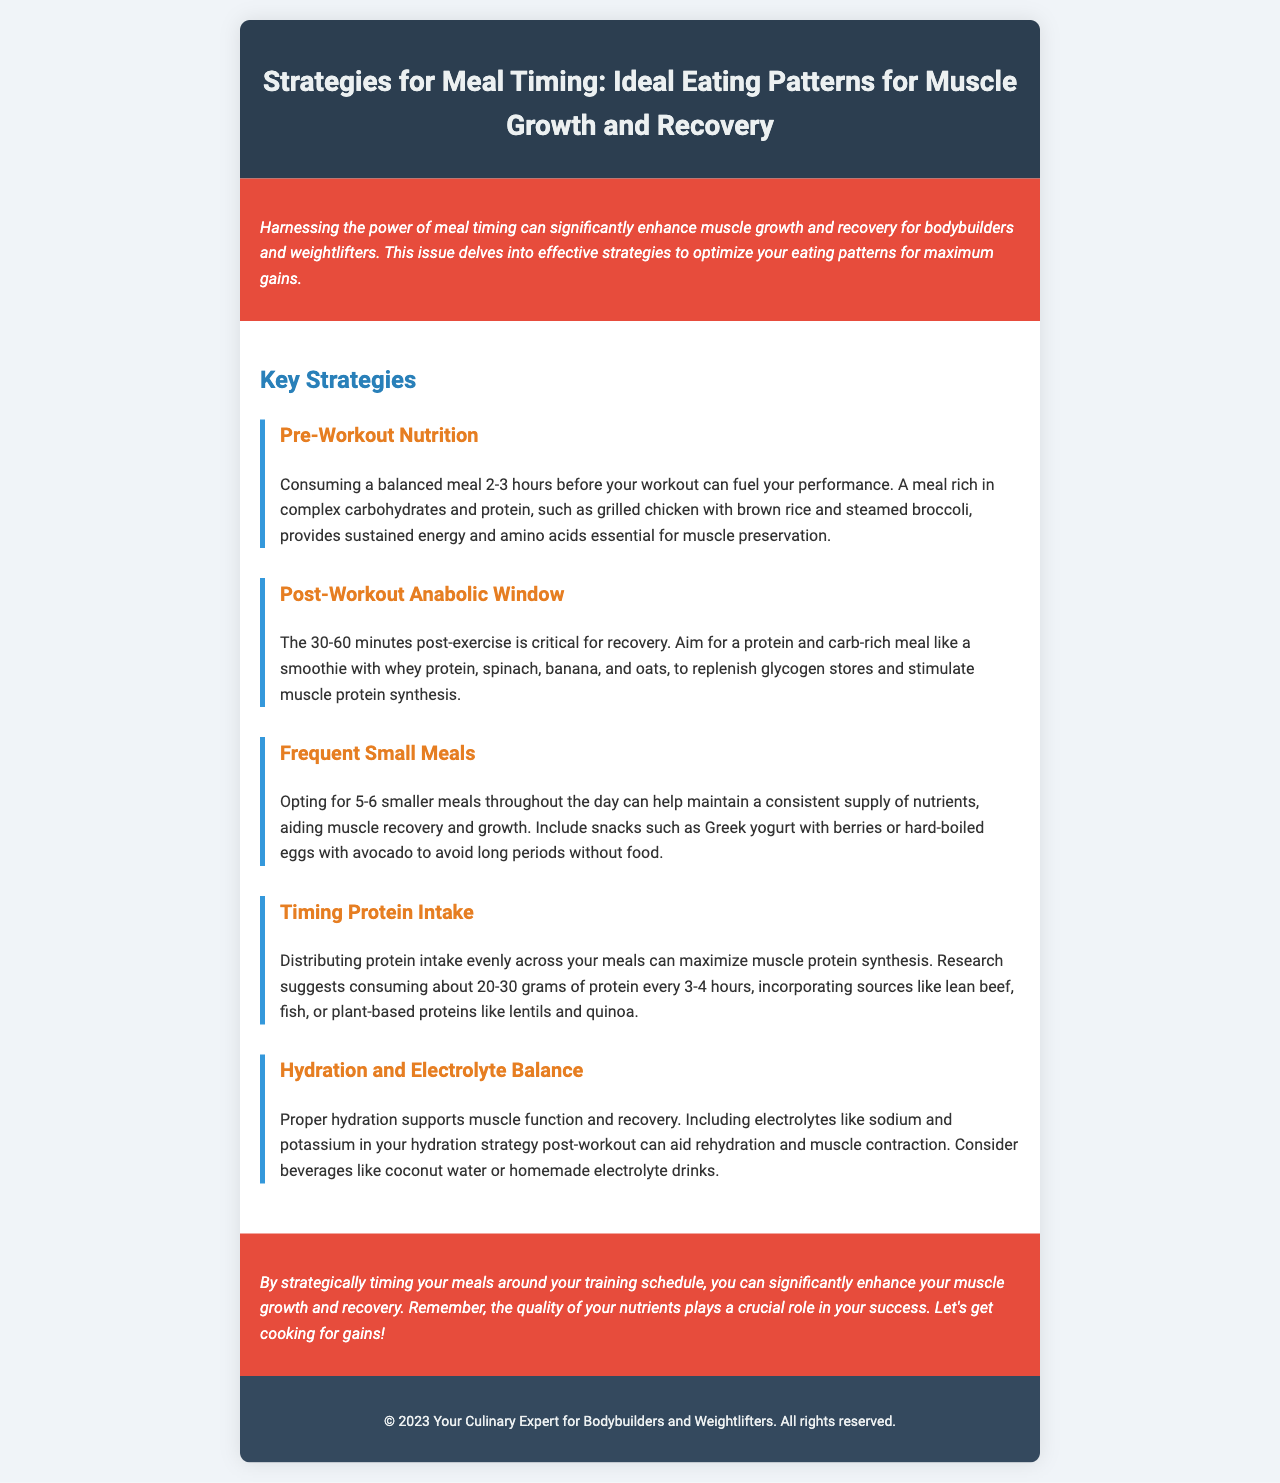What is the main focus of the newsletter? The newsletter focuses on strategies for meal timing to enhance muscle growth and recovery.
Answer: strategies for meal timing How many key strategies are discussed? The document outlines five distinct key strategies for meal timing.
Answer: five What type of meal is suggested for pre-workout nutrition? A balanced meal rich in complex carbohydrates and protein is suggested.
Answer: grilled chicken with brown rice and steamed broccoli What is the recommended timing for post-workout nutrition? The recommended timing for post-workout nutrition is within 30-60 minutes after exercise.
Answer: 30-60 minutes What should protein intake distribution look like? The document suggests consuming about 20-30 grams of protein every 3-4 hours.
Answer: 20-30 grams every 3-4 hours What is advised for maintaining hydration? Including electrolytes like sodium and potassium in your hydration strategy is advised.
Answer: electrolytes like sodium and potassium What culinary item is included in the post-workout meal suggestion? A smoothie is included as part of the post-workout meal suggestion.
Answer: smoothie What is the purpose of frequent small meals? Frequent small meals help maintain a consistent supply of nutrients.
Answer: maintain a consistent supply of nutrients 